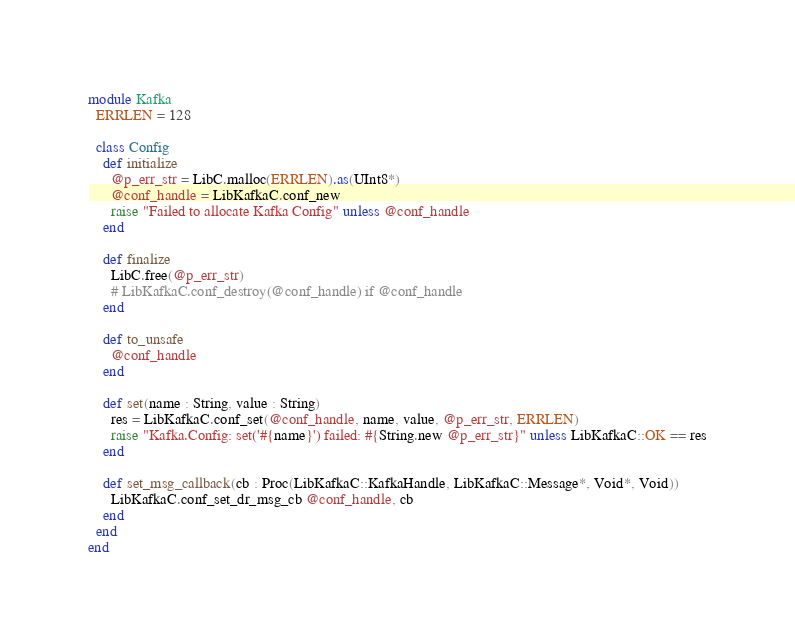<code> <loc_0><loc_0><loc_500><loc_500><_Crystal_>module Kafka
  ERRLEN = 128

  class Config
    def initialize
      @p_err_str = LibC.malloc(ERRLEN).as(UInt8*)
      @conf_handle = LibKafkaC.conf_new
      raise "Failed to allocate Kafka Config" unless @conf_handle
    end

    def finalize
      LibC.free(@p_err_str)
      # LibKafkaC.conf_destroy(@conf_handle) if @conf_handle
    end

    def to_unsafe
      @conf_handle
    end

    def set(name : String, value : String)
      res = LibKafkaC.conf_set(@conf_handle, name, value, @p_err_str, ERRLEN)
      raise "Kafka.Config: set('#{name}') failed: #{String.new @p_err_str}" unless LibKafkaC::OK == res
    end

    def set_msg_callback(cb : Proc(LibKafkaC::KafkaHandle, LibKafkaC::Message*, Void*, Void))
      LibKafkaC.conf_set_dr_msg_cb @conf_handle, cb
    end
  end
end
</code> 